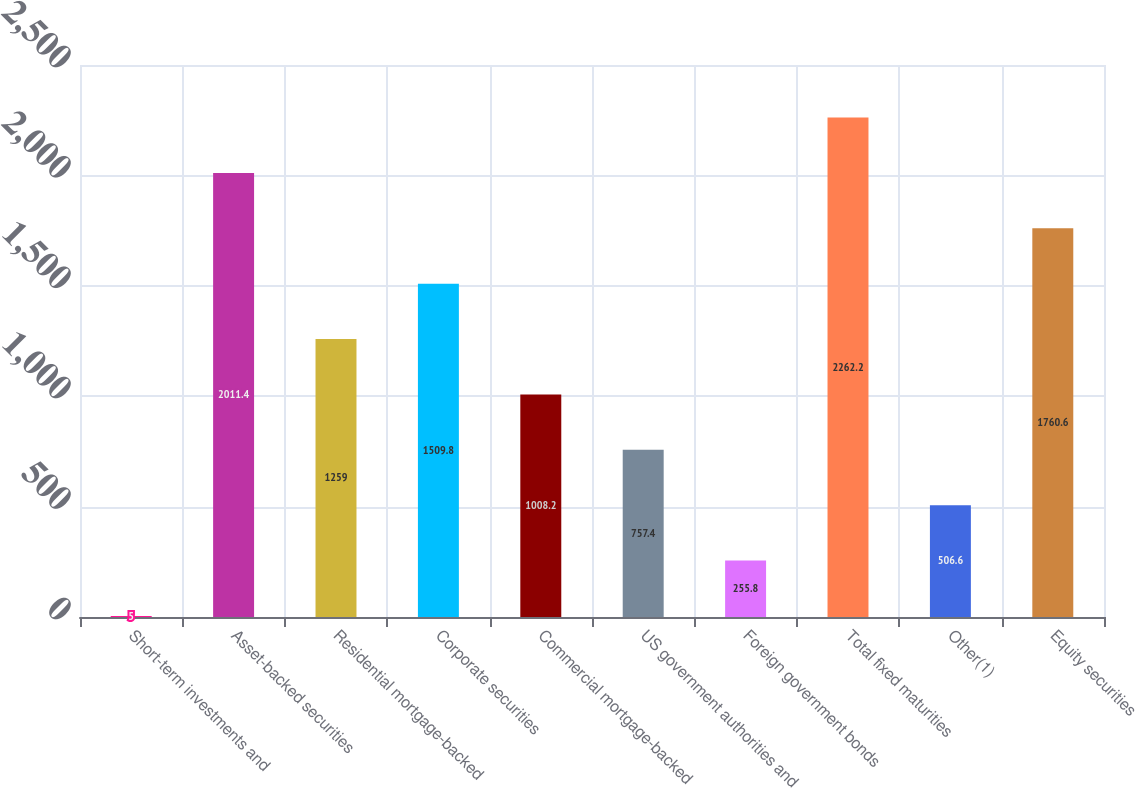Convert chart to OTSL. <chart><loc_0><loc_0><loc_500><loc_500><bar_chart><fcel>Short-term investments and<fcel>Asset-backed securities<fcel>Residential mortgage-backed<fcel>Corporate securities<fcel>Commercial mortgage-backed<fcel>US government authorities and<fcel>Foreign government bonds<fcel>Total fixed maturities<fcel>Other(1)<fcel>Equity securities<nl><fcel>5<fcel>2011.4<fcel>1259<fcel>1509.8<fcel>1008.2<fcel>757.4<fcel>255.8<fcel>2262.2<fcel>506.6<fcel>1760.6<nl></chart> 